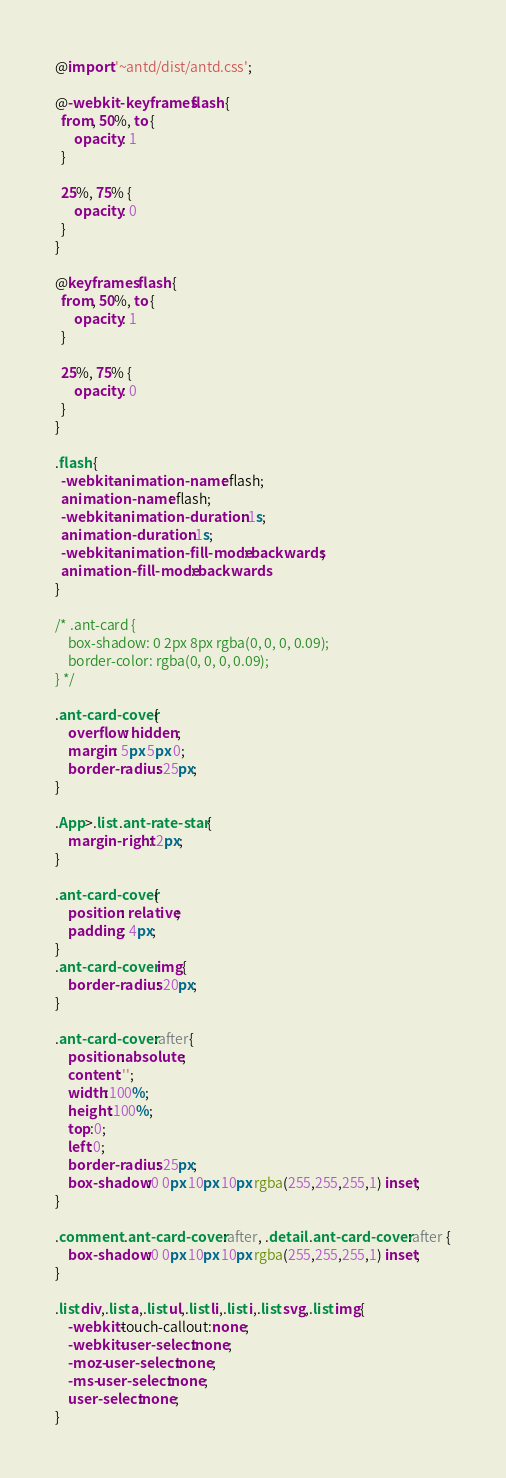Convert code to text. <code><loc_0><loc_0><loc_500><loc_500><_CSS_>@import '~antd/dist/antd.css';

@-webkit-keyframes flash {
  from, 50%, to {
      opacity: 1
  }

  25%, 75% {
      opacity: 0
  }
}

@keyframes flash {
  from, 50%, to {
      opacity: 1
  }

  25%, 75% {
      opacity: 0
  }
}

.flash {
  -webkit-animation-name: flash;
  animation-name: flash;
  -webkit-animation-duration: 1s;
  animation-duration: 1s;
  -webkit-animation-fill-mode: backwards;
  animation-fill-mode: backwards
}

/* .ant-card {
    box-shadow: 0 2px 8px rgba(0, 0, 0, 0.09);
    border-color: rgba(0, 0, 0, 0.09);
} */

.ant-card-cover{
    overflow: hidden;
    margin: 5px 5px 0;
    border-radius: 25px;
}

.App>.list .ant-rate-star {
    margin-right: 2px;
}

.ant-card-cover{
    position: relative;
    padding: 4px;
}
.ant-card-cover img{
    border-radius: 20px;
}

.ant-card-cover:after{
    position:absolute;
    content:'';
    width:100%;
    height:100%;
    top:0;
    left:0;
    border-radius: 25px;
    box-shadow:0 0px 10px 10px rgba(255,255,255,1) inset;
}

.comment .ant-card-cover:after, .detail .ant-card-cover:after {
    box-shadow:0 0px 10px 10px rgba(255,255,255,1) inset;
}

.list div,.list a,.list ul,.list li,.list i,.list svg,.list img{
    -webkit-touch-callout:none; 
    -webkit-user-select:none; 
    -moz-user-select:none;
    -ms-user-select:none; 
    user-select:none;
}

</code> 